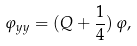Convert formula to latex. <formula><loc_0><loc_0><loc_500><loc_500>\varphi _ { y y } = ( Q + \frac { 1 } { 4 } ) \, \varphi ,</formula> 